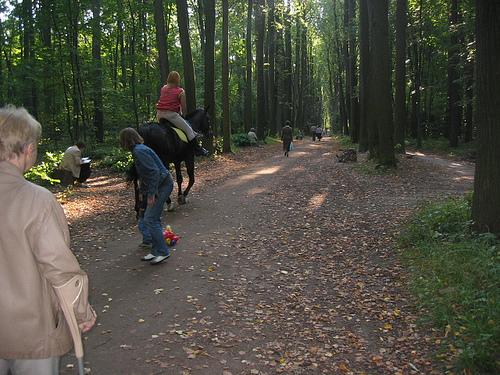Are there any trees in this image?
Write a very short answer. Yes. What is the person riding on?
Give a very brief answer. Horse. What is that guy riding?
Short answer required. Horse. What is the man on the hill carrying?
Quick response, please. Bag. What are they riding on?
Give a very brief answer. Horse. What is the woman in gray looking at?
Quick response, please. Horse. How many people are in this picture?
Short answer required. 8. Is the man afraid of the horse?
Short answer required. No. Would these people dress like this every day?
Be succinct. Yes. What time of year was the photo taken?
Short answer required. Fall. In what U.S. State might this picture have been taken?
Keep it brief. California. What are the people doing?
Keep it brief. Walking. What are they riding?
Concise answer only. Horses. 